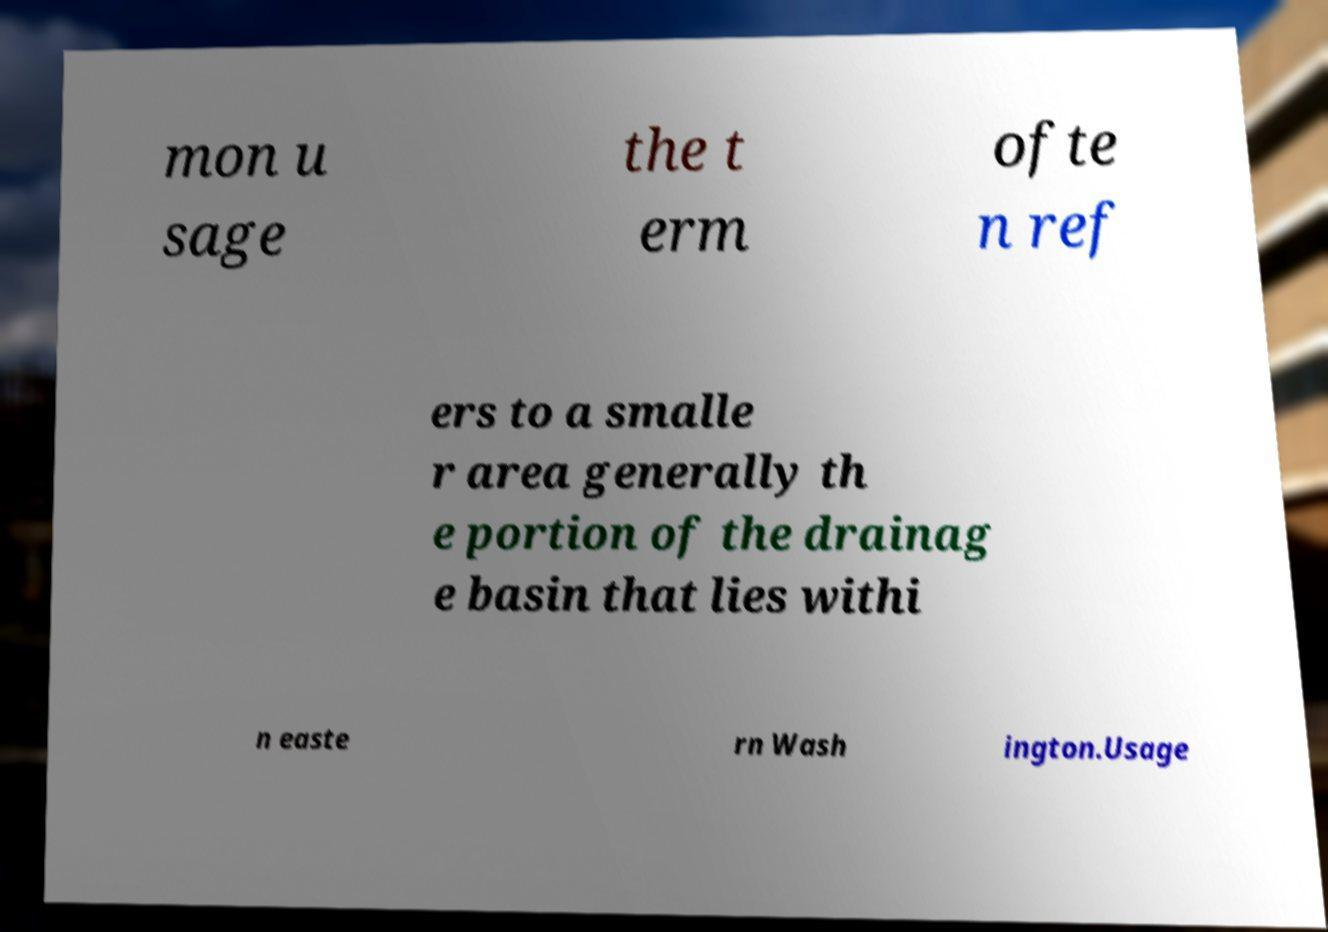There's text embedded in this image that I need extracted. Can you transcribe it verbatim? mon u sage the t erm ofte n ref ers to a smalle r area generally th e portion of the drainag e basin that lies withi n easte rn Wash ington.Usage 